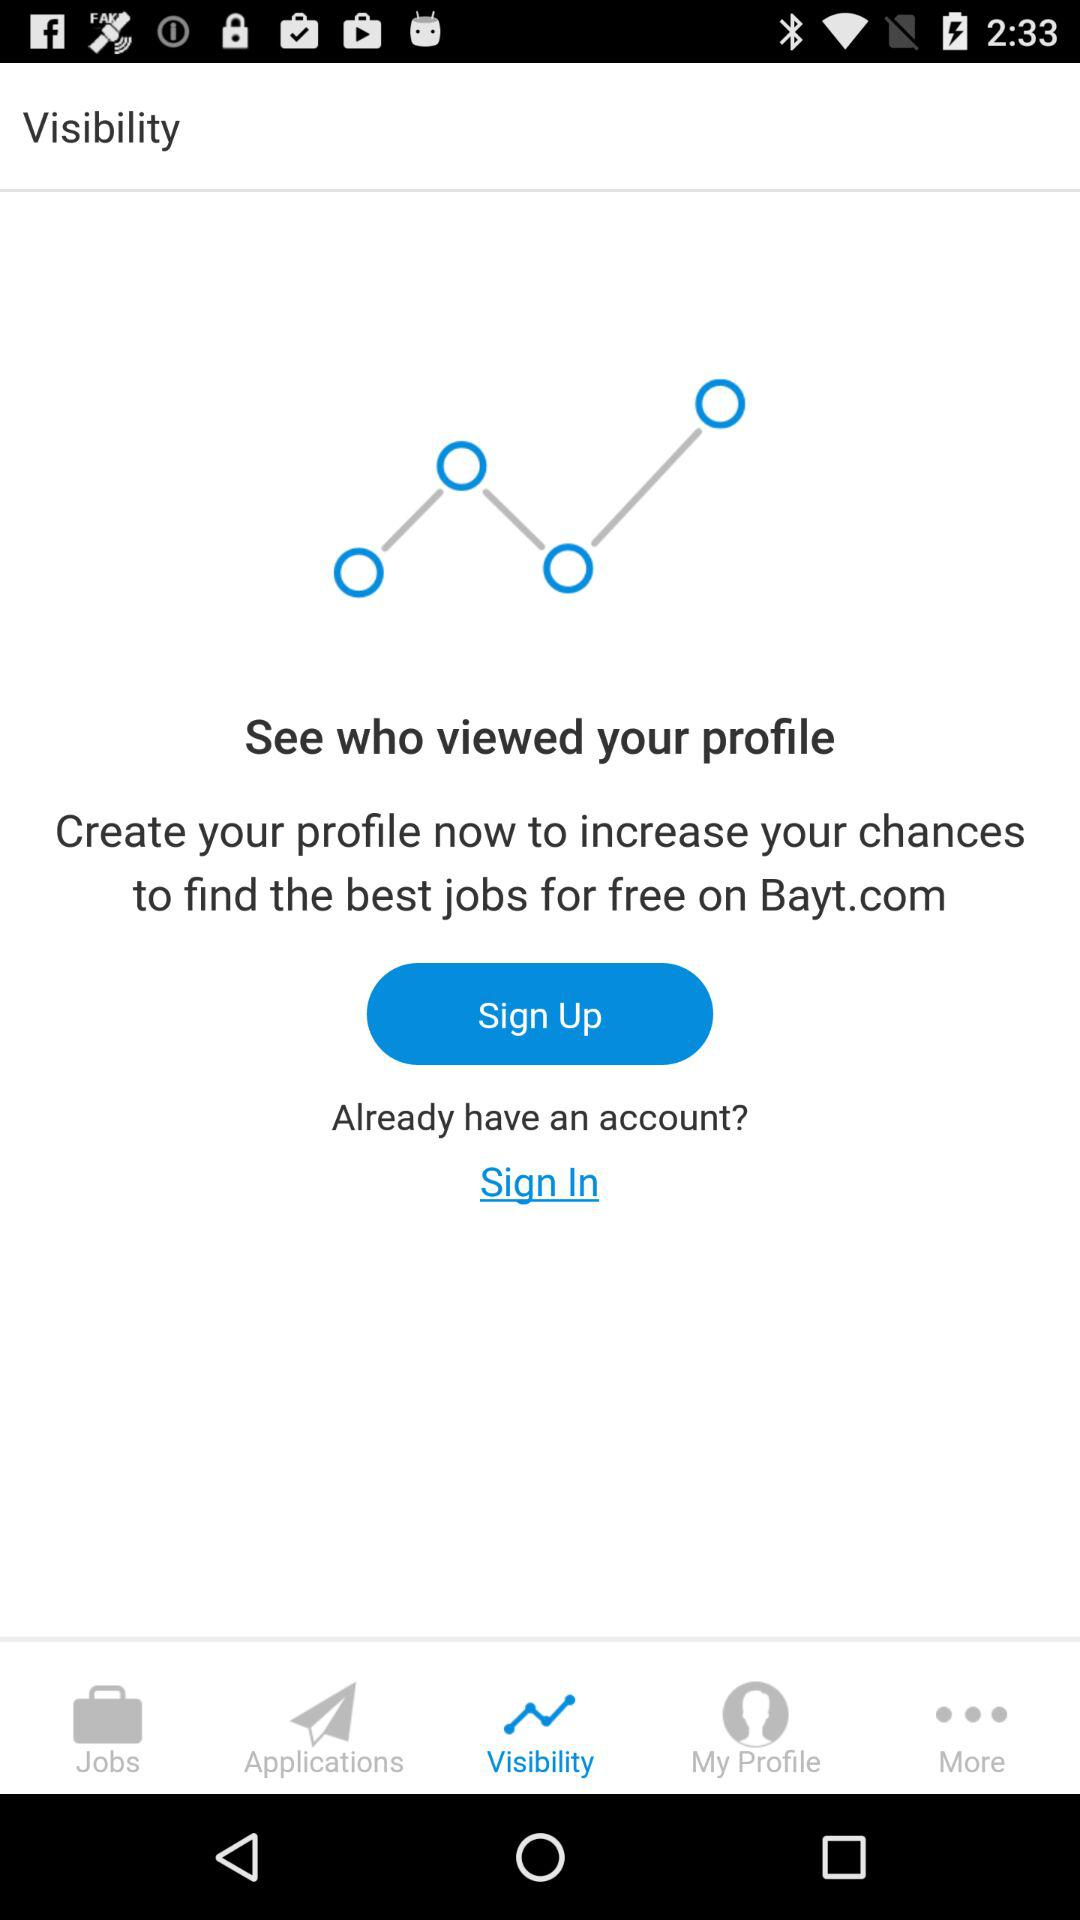Which tab is selected? The selected tab is "Visibility". 